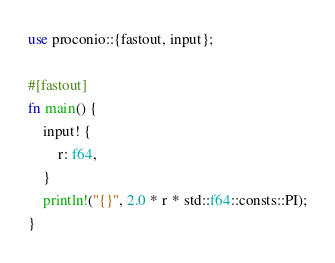Convert code to text. <code><loc_0><loc_0><loc_500><loc_500><_Rust_>use proconio::{fastout, input};

#[fastout]
fn main() {
    input! {
        r: f64,
    }
    println!("{}", 2.0 * r * std::f64::consts::PI);
}
</code> 